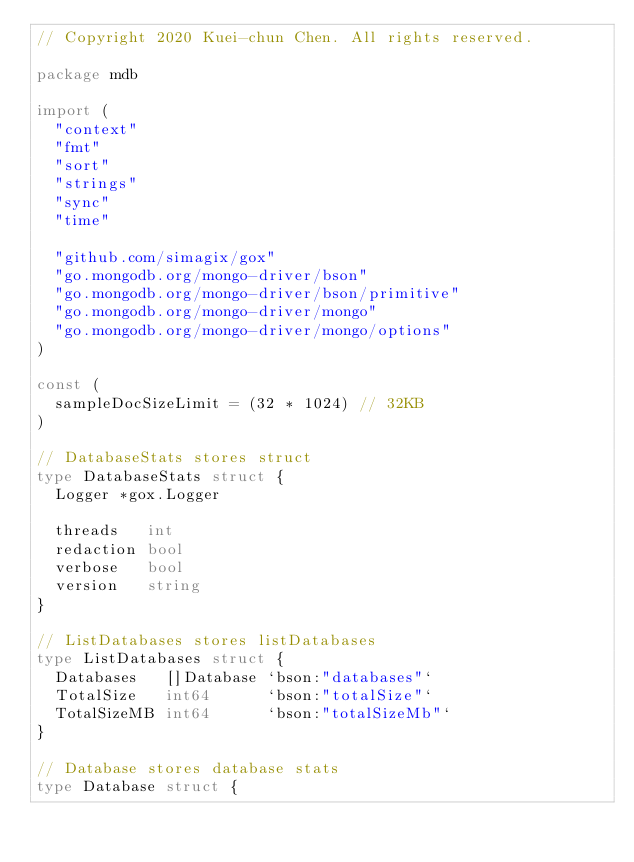<code> <loc_0><loc_0><loc_500><loc_500><_Go_>// Copyright 2020 Kuei-chun Chen. All rights reserved.

package mdb

import (
	"context"
	"fmt"
	"sort"
	"strings"
	"sync"
	"time"

	"github.com/simagix/gox"
	"go.mongodb.org/mongo-driver/bson"
	"go.mongodb.org/mongo-driver/bson/primitive"
	"go.mongodb.org/mongo-driver/mongo"
	"go.mongodb.org/mongo-driver/mongo/options"
)

const (
	sampleDocSizeLimit = (32 * 1024) // 32KB
)

// DatabaseStats stores struct
type DatabaseStats struct {
	Logger *gox.Logger

	threads   int
	redaction bool
	verbose   bool
	version   string
}

// ListDatabases stores listDatabases
type ListDatabases struct {
	Databases   []Database `bson:"databases"`
	TotalSize   int64      `bson:"totalSize"`
	TotalSizeMB int64      `bson:"totalSizeMb"`
}

// Database stores database stats
type Database struct {</code> 